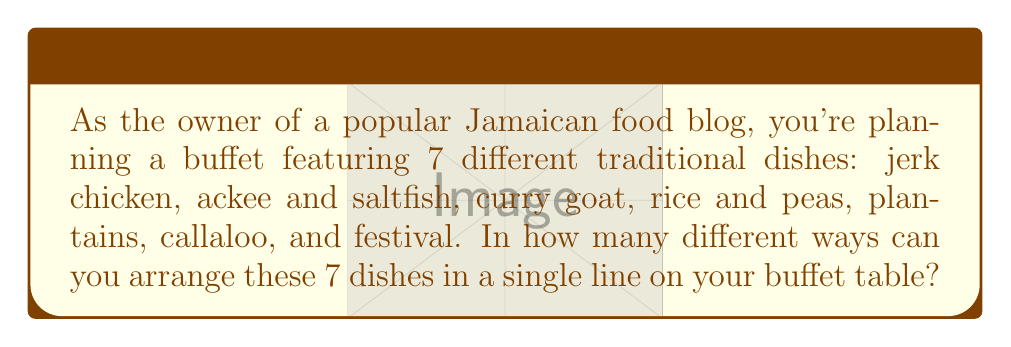Help me with this question. Let's approach this step-by-step:

1) This problem is a classic example of permutation. We need to find the number of ways to arrange 7 distinct items in a line.

2) In permutation problems, the order matters. Each unique arrangement of the 7 dishes is considered a different permutation.

3) For the first position, we have 7 choices of dishes to place.

4) After placing the first dish, we have 6 choices for the second position.

5) For the third position, we have 5 choices, and so on.

6) This continues until we place the last dish, for which we have only 1 choice left.

7) Therefore, the total number of ways to arrange the dishes is:

   $$7 \times 6 \times 5 \times 4 \times 3 \times 2 \times 1$$

8) This is also known as 7 factorial, written as 7!

9) Calculating this:
   $$7! = 7 \times 6 \times 5 \times 4 \times 3 \times 2 \times 1 = 5040$$

Thus, there are 5040 different ways to arrange the 7 Jamaican dishes on the buffet table.
Answer: $7! = 5040$ 